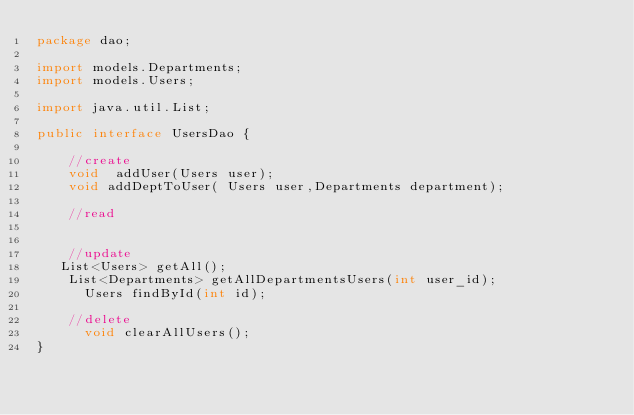<code> <loc_0><loc_0><loc_500><loc_500><_Java_>package dao;

import models.Departments;
import models.Users;

import java.util.List;

public interface UsersDao {

    //create
    void  addUser(Users user);
    void addDeptToUser( Users user,Departments department);

    //read


    //update
   List<Users> getAll();
    List<Departments> getAllDepartmentsUsers(int user_id);
      Users findById(int id);

    //delete
      void clearAllUsers();
}
</code> 